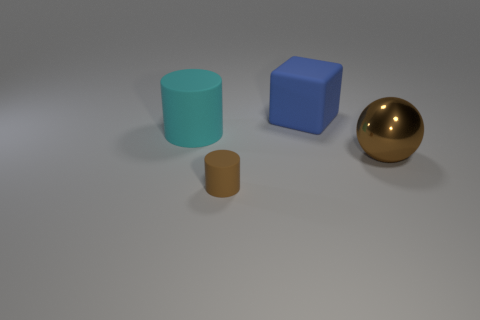Add 4 tiny brown things. How many objects exist? 8 Subtract all spheres. How many objects are left? 3 Add 4 big blue objects. How many big blue objects are left? 5 Add 3 big green matte objects. How many big green matte objects exist? 3 Subtract 0 green balls. How many objects are left? 4 Subtract all brown cylinders. Subtract all cyan balls. How many cylinders are left? 1 Subtract all big blue matte cubes. Subtract all cyan matte objects. How many objects are left? 2 